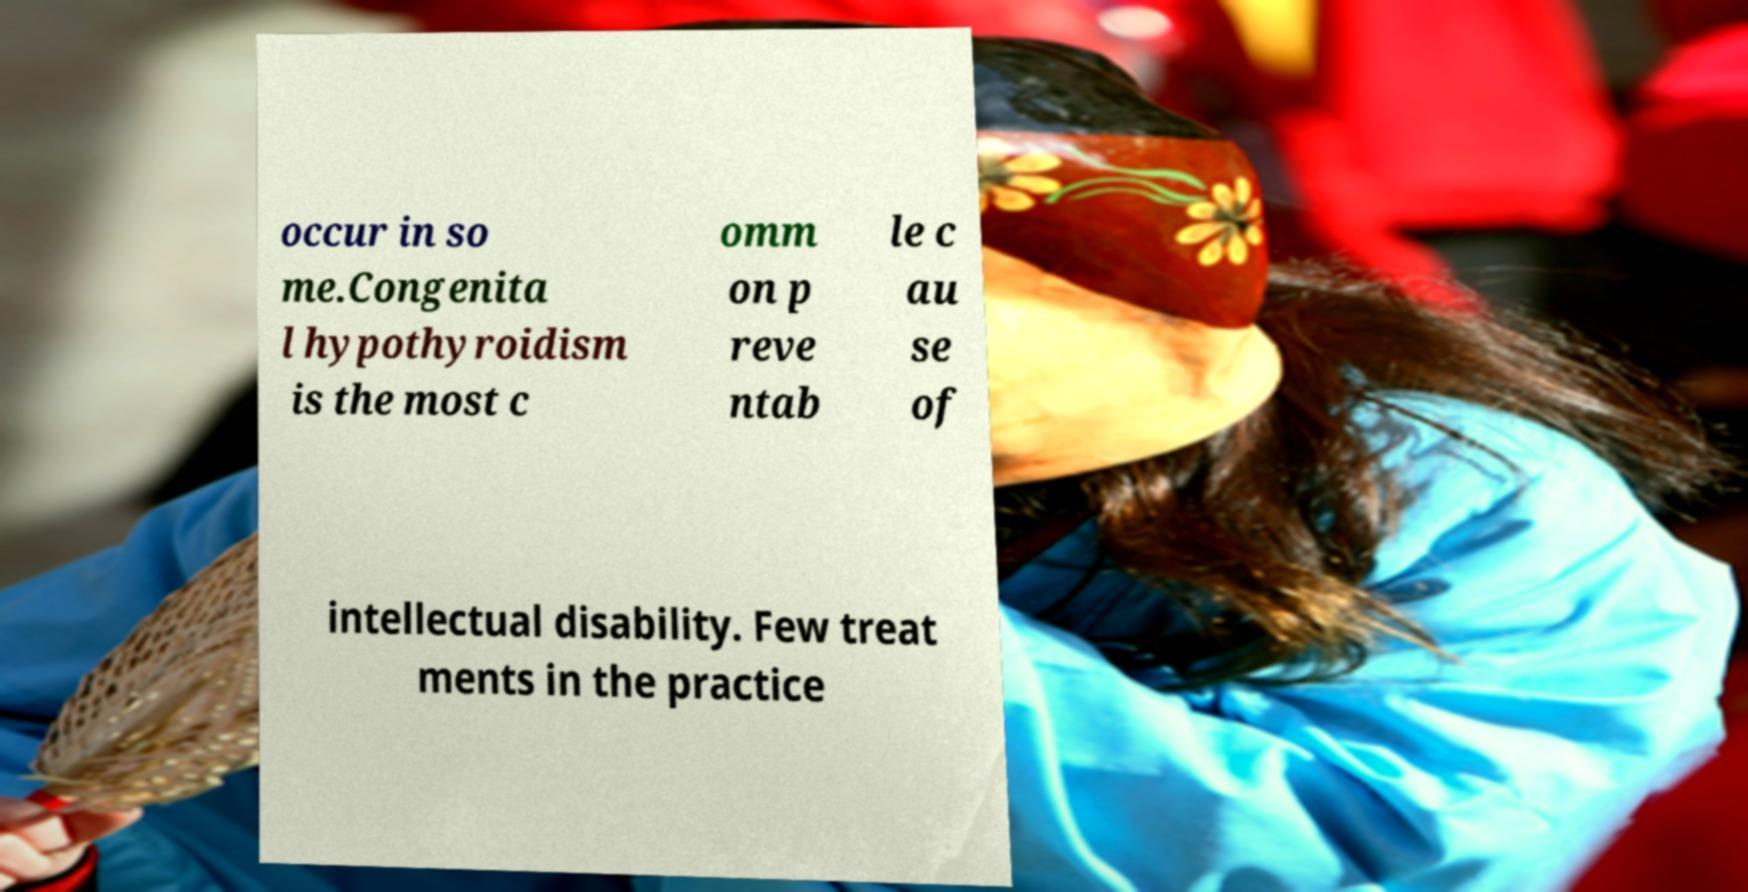Please identify and transcribe the text found in this image. occur in so me.Congenita l hypothyroidism is the most c omm on p reve ntab le c au se of intellectual disability. Few treat ments in the practice 